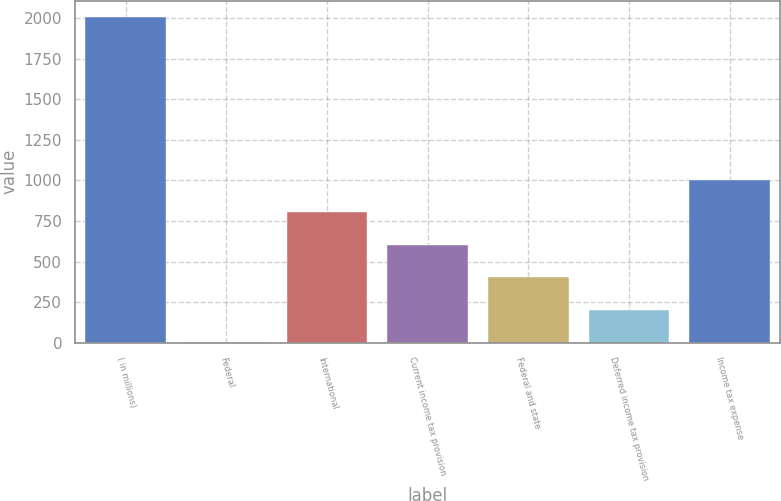Convert chart. <chart><loc_0><loc_0><loc_500><loc_500><bar_chart><fcel>( in millions)<fcel>Federal<fcel>International<fcel>Current income tax provision<fcel>Federal and state<fcel>Deferred income tax provision<fcel>Income tax expense<nl><fcel>2008<fcel>2.8<fcel>804.88<fcel>604.36<fcel>403.84<fcel>203.32<fcel>1005.4<nl></chart> 